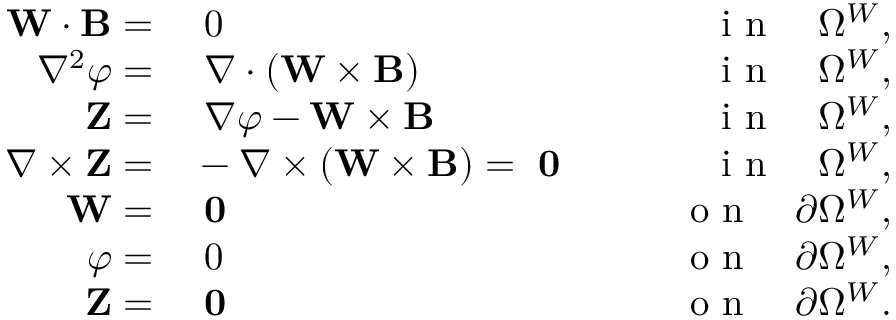<formula> <loc_0><loc_0><loc_500><loc_500>\begin{array} { r l r } { W \cdot { \mathbf B } = } & 0 } & { \quad i n \quad \Omega ^ { W } , } \\ { \nabla ^ { 2 } { \varphi } = } & \nabla \cdot \left ( W \times { \mathbf B } \right ) } & { \quad i n \quad \Omega ^ { W } , } \\ { Z = } & \nabla \varphi - W \times { \mathbf B } } & { \quad i n \quad \Omega ^ { W } , } \\ { \nabla \times Z = } & - \nabla \times ( W \times { \mathbf B } ) = 0 } & { \quad i n \quad \Omega ^ { W } , } \\ { W = } & 0 } & { \quad o n \quad \partial \Omega ^ { W } , } \\ { \varphi = } & 0 } & { \quad o n \quad \partial \Omega ^ { W } , } \\ { Z = } & 0 } & { \quad o n \quad \partial \Omega ^ { W } . } \end{array}</formula> 